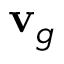Convert formula to latex. <formula><loc_0><loc_0><loc_500><loc_500>{ v } _ { g }</formula> 